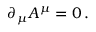<formula> <loc_0><loc_0><loc_500><loc_500>\partial _ { \mu } A ^ { \mu } = 0 \, .</formula> 